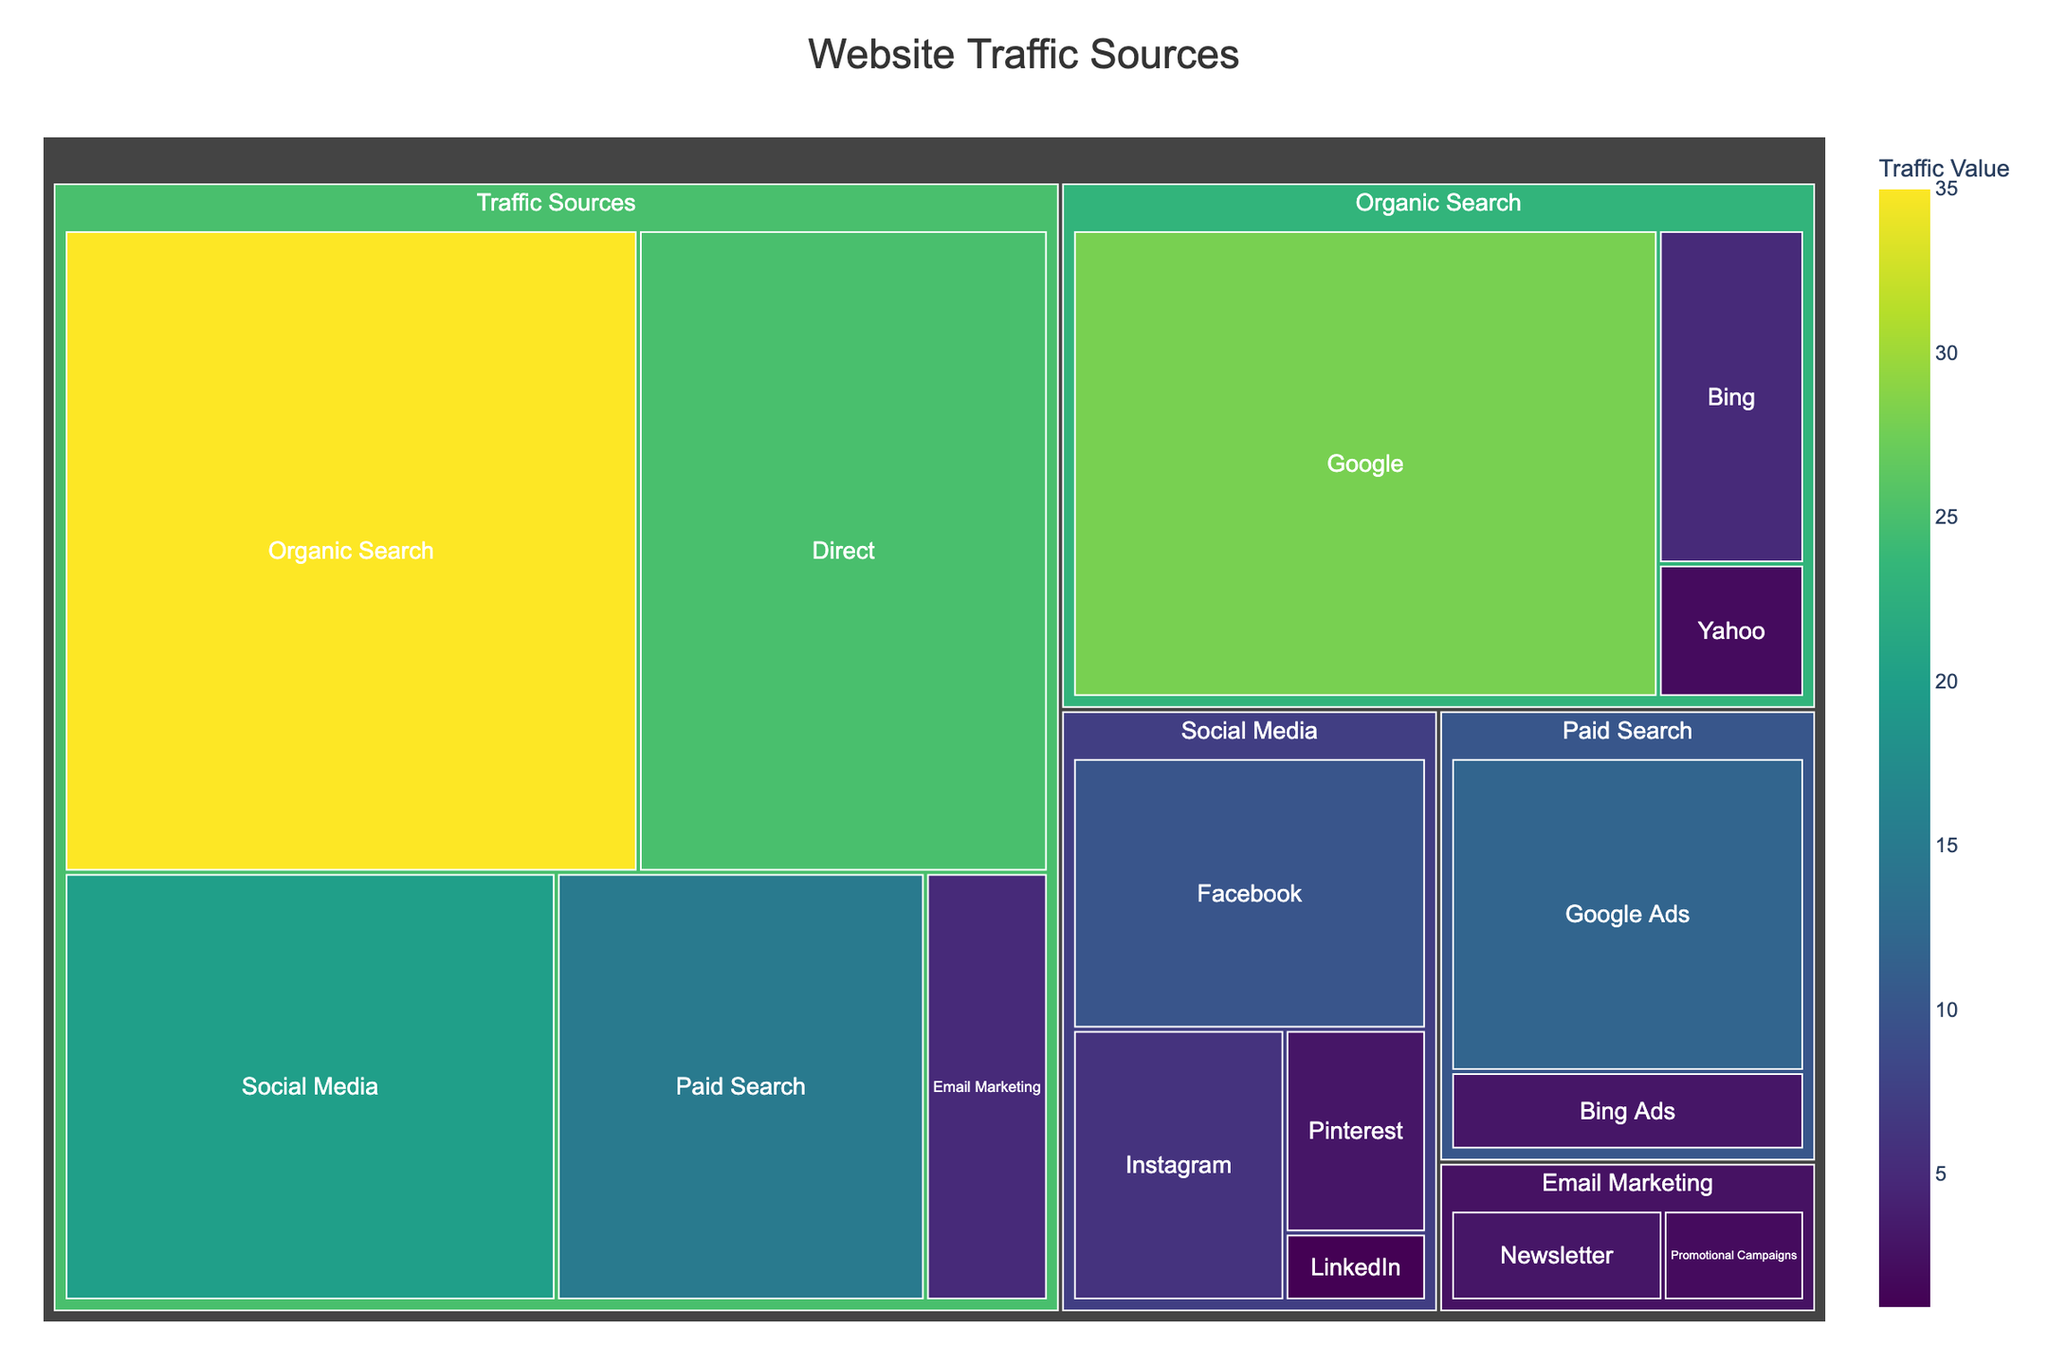What's the title of the figure? The title is usually prominently displayed at the top of the treemap. Here, it is "Website Traffic Sources".
Answer: Website Traffic Sources How many main categories are displayed in the treemap? The treemap divides the data into main categories based on the 'parent' entries. The treemap has 5 main categories: Organic Search, Direct, Social Media, Paid Search, and Email Marketing.
Answer: 5 Which traffic source has the largest value? The size of each section in the treemap represents its value. The largest section is for "Organic Search" which has the highest traffic value of 35.
Answer: Organic Search What's the sum of traffic values from Social Media? To find the total traffic from Social Media, sum the individual values of its subcategories: Facebook (10) + Instagram (6) + Pinterest (3) + LinkedIn (1) = 20.
Answer: 20 Compare the values of Organic Search traffic from Google and Bing. Which one is higher? The treemap shows Organic Search traffic from Google with a value of 28 and Bing with a value of 5. Google has a higher value than Bing.
Answer: Google What is the relative position of the traffic sources "Email Marketing" and "Paid Search"? By looking at the treemap, you can see that the "Paid Search" section is larger than the "Email Marketing" section, indicating that "Paid Search" has a higher traffic value.
Answer: Paid Search is larger How much higher is the traffic value of Direct compared to Paid Search? The values are Direct (25) and Paid Search (15). Subtract the value of Paid Search from Direct: 25 - 15 = 10. Direct traffic is 10 higher than Paid Search.
Answer: 10 What are the subcategories of Paid Search? The subcategories of Paid Search as indicated in the treemap are "Google Ads" and "Bing Ads".
Answer: Google Ads, Bing Ads Which subcategory has the smallest traffic value and what is its value? The smallest traffic value is found in the "Social Media" category under the subcategory "LinkedIn" with a value of 1.
Answer: LinkedIn, 1 What is the combined traffic value of the sources attributed to Google? For this, add the values of "Google" in Organic Search (28) and "Google Ads" in Paid Search (12): 28 + 12 = 40.
Answer: 40 